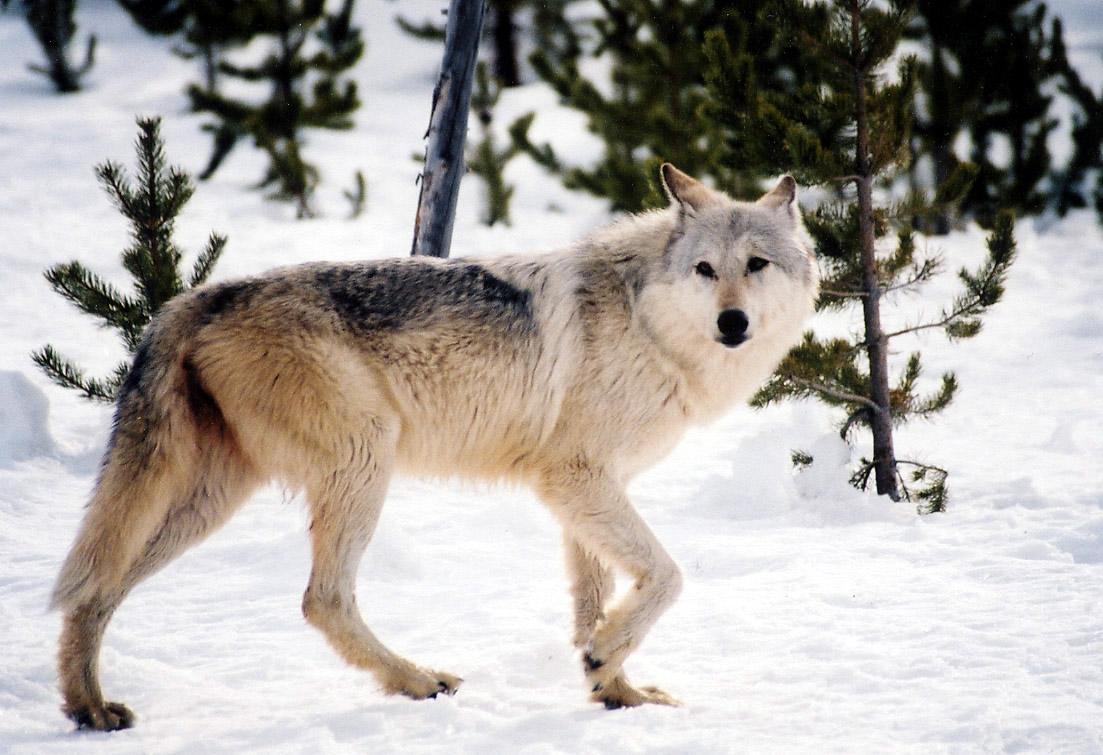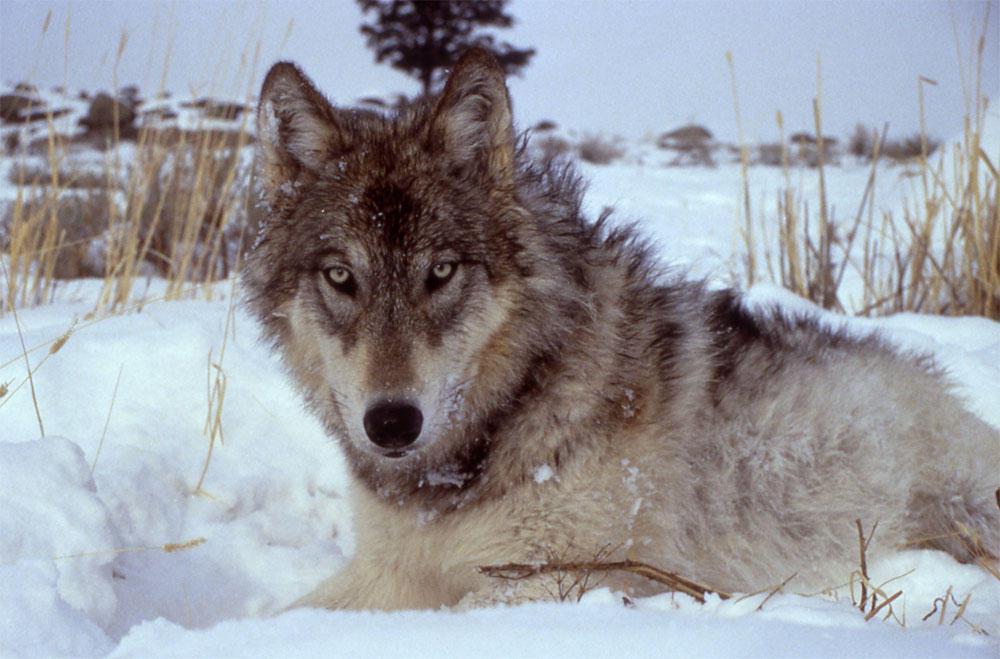The first image is the image on the left, the second image is the image on the right. For the images shown, is this caption "One image shows a wolf standing on snow in front of trees with its body turned rightward and its head facing the camera." true? Answer yes or no. Yes. The first image is the image on the left, the second image is the image on the right. Given the left and right images, does the statement "There is no more than two wolves in the left image." hold true? Answer yes or no. Yes. 